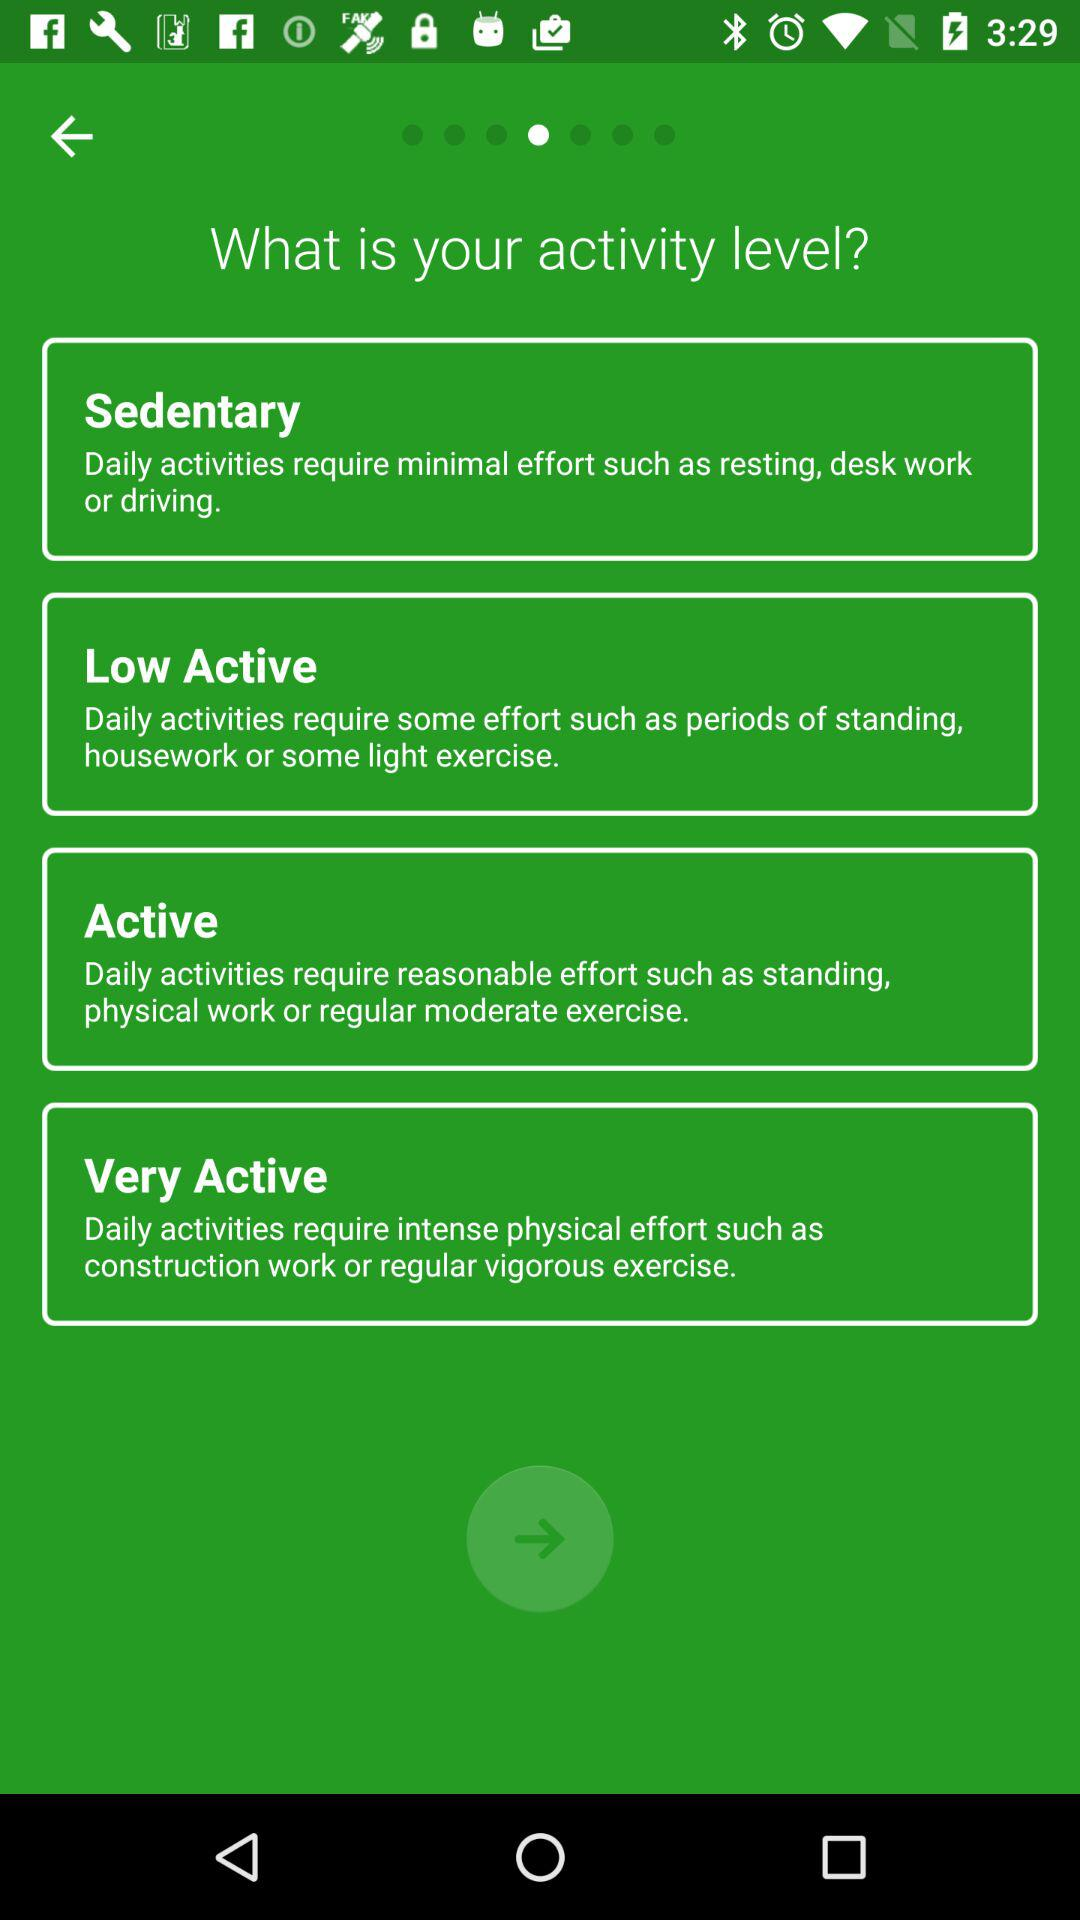How many activity levels are available?
Answer the question using a single word or phrase. 4 